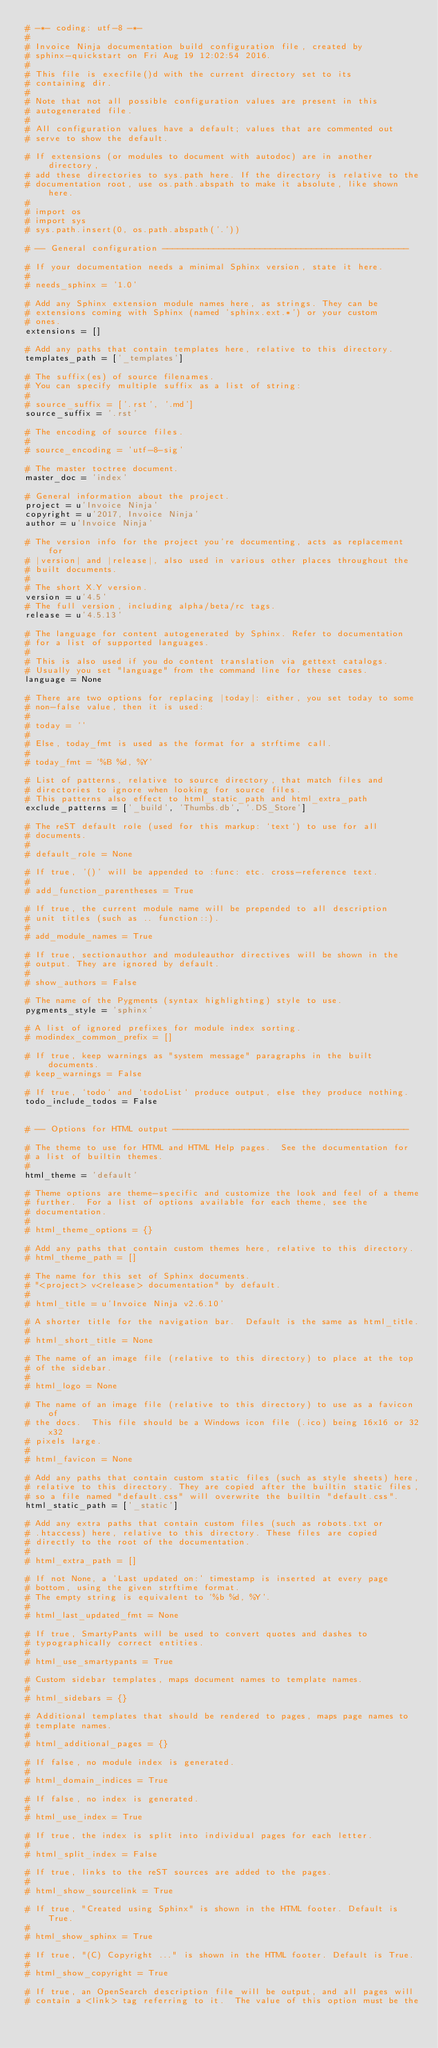<code> <loc_0><loc_0><loc_500><loc_500><_Python_># -*- coding: utf-8 -*-
#
# Invoice Ninja documentation build configuration file, created by
# sphinx-quickstart on Fri Aug 19 12:02:54 2016.
#
# This file is execfile()d with the current directory set to its
# containing dir.
#
# Note that not all possible configuration values are present in this
# autogenerated file.
#
# All configuration values have a default; values that are commented out
# serve to show the default.

# If extensions (or modules to document with autodoc) are in another directory,
# add these directories to sys.path here. If the directory is relative to the
# documentation root, use os.path.abspath to make it absolute, like shown here.
#
# import os
# import sys
# sys.path.insert(0, os.path.abspath('.'))

# -- General configuration ------------------------------------------------

# If your documentation needs a minimal Sphinx version, state it here.
#
# needs_sphinx = '1.0'

# Add any Sphinx extension module names here, as strings. They can be
# extensions coming with Sphinx (named 'sphinx.ext.*') or your custom
# ones.
extensions = []

# Add any paths that contain templates here, relative to this directory.
templates_path = ['_templates']

# The suffix(es) of source filenames.
# You can specify multiple suffix as a list of string:
#
# source_suffix = ['.rst', '.md']
source_suffix = '.rst'

# The encoding of source files.
#
# source_encoding = 'utf-8-sig'

# The master toctree document.
master_doc = 'index'

# General information about the project.
project = u'Invoice Ninja'
copyright = u'2017, Invoice Ninja'
author = u'Invoice Ninja'

# The version info for the project you're documenting, acts as replacement for
# |version| and |release|, also used in various other places throughout the
# built documents.
#
# The short X.Y version.
version = u'4.5'
# The full version, including alpha/beta/rc tags.
release = u'4.5.13'

# The language for content autogenerated by Sphinx. Refer to documentation
# for a list of supported languages.
#
# This is also used if you do content translation via gettext catalogs.
# Usually you set "language" from the command line for these cases.
language = None

# There are two options for replacing |today|: either, you set today to some
# non-false value, then it is used:
#
# today = ''
#
# Else, today_fmt is used as the format for a strftime call.
#
# today_fmt = '%B %d, %Y'

# List of patterns, relative to source directory, that match files and
# directories to ignore when looking for source files.
# This patterns also effect to html_static_path and html_extra_path
exclude_patterns = ['_build', 'Thumbs.db', '.DS_Store']

# The reST default role (used for this markup: `text`) to use for all
# documents.
#
# default_role = None

# If true, '()' will be appended to :func: etc. cross-reference text.
#
# add_function_parentheses = True

# If true, the current module name will be prepended to all description
# unit titles (such as .. function::).
#
# add_module_names = True

# If true, sectionauthor and moduleauthor directives will be shown in the
# output. They are ignored by default.
#
# show_authors = False

# The name of the Pygments (syntax highlighting) style to use.
pygments_style = 'sphinx'

# A list of ignored prefixes for module index sorting.
# modindex_common_prefix = []

# If true, keep warnings as "system message" paragraphs in the built documents.
# keep_warnings = False

# If true, `todo` and `todoList` produce output, else they produce nothing.
todo_include_todos = False


# -- Options for HTML output ----------------------------------------------

# The theme to use for HTML and HTML Help pages.  See the documentation for
# a list of builtin themes.
#
html_theme = 'default'

# Theme options are theme-specific and customize the look and feel of a theme
# further.  For a list of options available for each theme, see the
# documentation.
#
# html_theme_options = {}

# Add any paths that contain custom themes here, relative to this directory.
# html_theme_path = []

# The name for this set of Sphinx documents.
# "<project> v<release> documentation" by default.
#
# html_title = u'Invoice Ninja v2.6.10'

# A shorter title for the navigation bar.  Default is the same as html_title.
#
# html_short_title = None

# The name of an image file (relative to this directory) to place at the top
# of the sidebar.
#
# html_logo = None

# The name of an image file (relative to this directory) to use as a favicon of
# the docs.  This file should be a Windows icon file (.ico) being 16x16 or 32x32
# pixels large.
#
# html_favicon = None

# Add any paths that contain custom static files (such as style sheets) here,
# relative to this directory. They are copied after the builtin static files,
# so a file named "default.css" will overwrite the builtin "default.css".
html_static_path = ['_static']

# Add any extra paths that contain custom files (such as robots.txt or
# .htaccess) here, relative to this directory. These files are copied
# directly to the root of the documentation.
#
# html_extra_path = []

# If not None, a 'Last updated on:' timestamp is inserted at every page
# bottom, using the given strftime format.
# The empty string is equivalent to '%b %d, %Y'.
#
# html_last_updated_fmt = None

# If true, SmartyPants will be used to convert quotes and dashes to
# typographically correct entities.
#
# html_use_smartypants = True

# Custom sidebar templates, maps document names to template names.
#
# html_sidebars = {}

# Additional templates that should be rendered to pages, maps page names to
# template names.
#
# html_additional_pages = {}

# If false, no module index is generated.
#
# html_domain_indices = True

# If false, no index is generated.
#
# html_use_index = True

# If true, the index is split into individual pages for each letter.
#
# html_split_index = False

# If true, links to the reST sources are added to the pages.
#
# html_show_sourcelink = True

# If true, "Created using Sphinx" is shown in the HTML footer. Default is True.
#
# html_show_sphinx = True

# If true, "(C) Copyright ..." is shown in the HTML footer. Default is True.
#
# html_show_copyright = True

# If true, an OpenSearch description file will be output, and all pages will
# contain a <link> tag referring to it.  The value of this option must be the</code> 